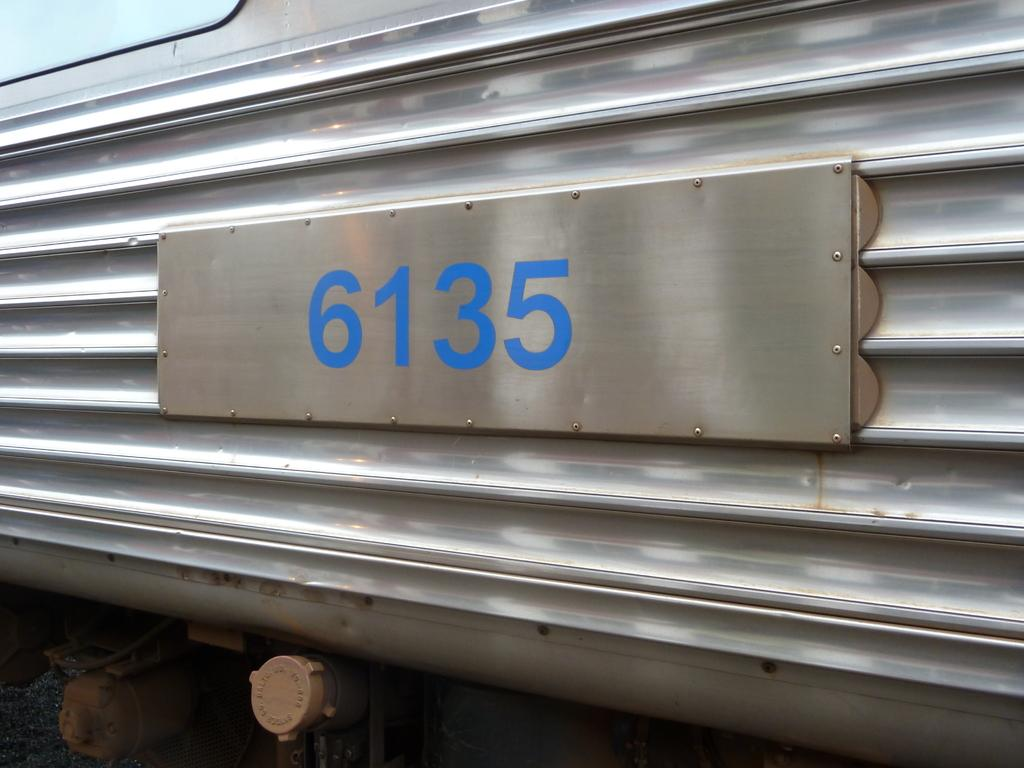What can be seen on the vehicle in the image? There is a number plate on a vehicle in the image. What type of brick is being used to build the hall in the image? There is no hall or brick present in the image; it only features a number plate on a vehicle. 